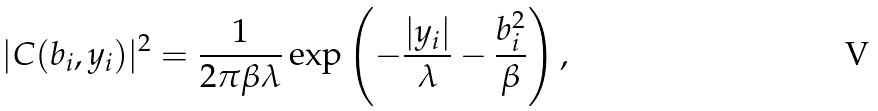<formula> <loc_0><loc_0><loc_500><loc_500>| C ( b _ { i } , y _ { i } ) | ^ { 2 } = \frac { 1 } { 2 \pi \beta \lambda } \exp \left ( - \frac { | y _ { i } | } { \lambda } - \frac { b _ { i } ^ { 2 } } { \beta } \right ) ,</formula> 